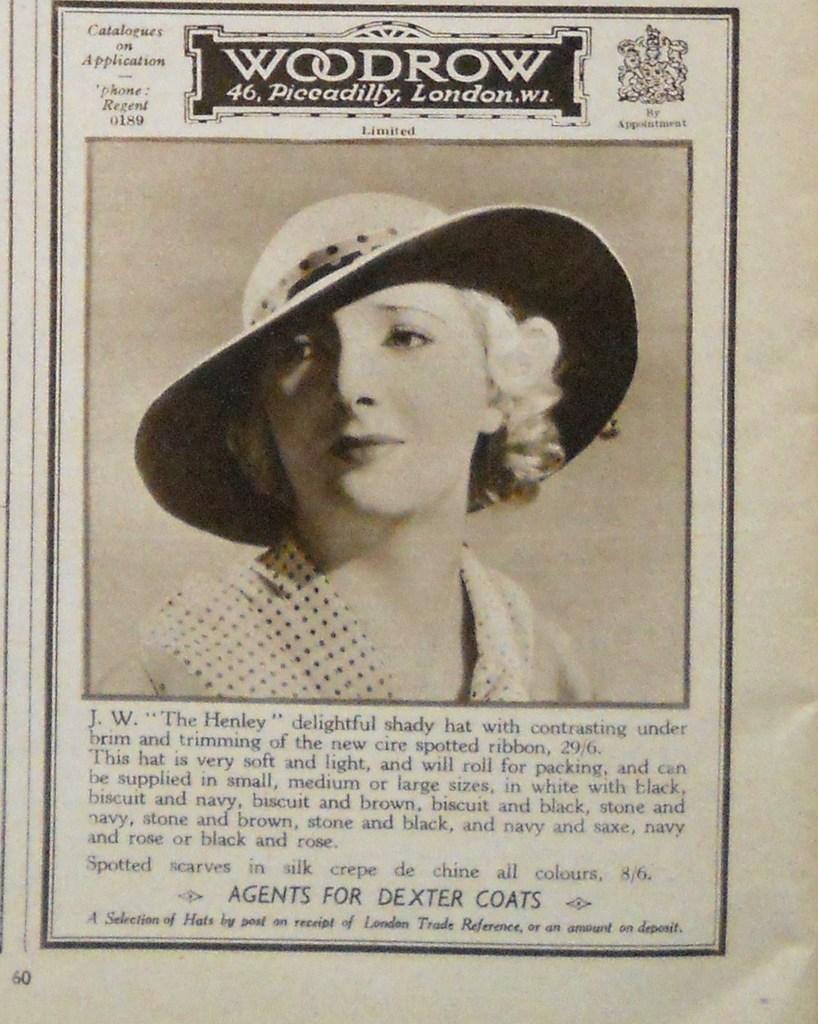Describe this image in one or two sentences. In this picture we can see a newspaper, in the newspaper we can find a woman. 